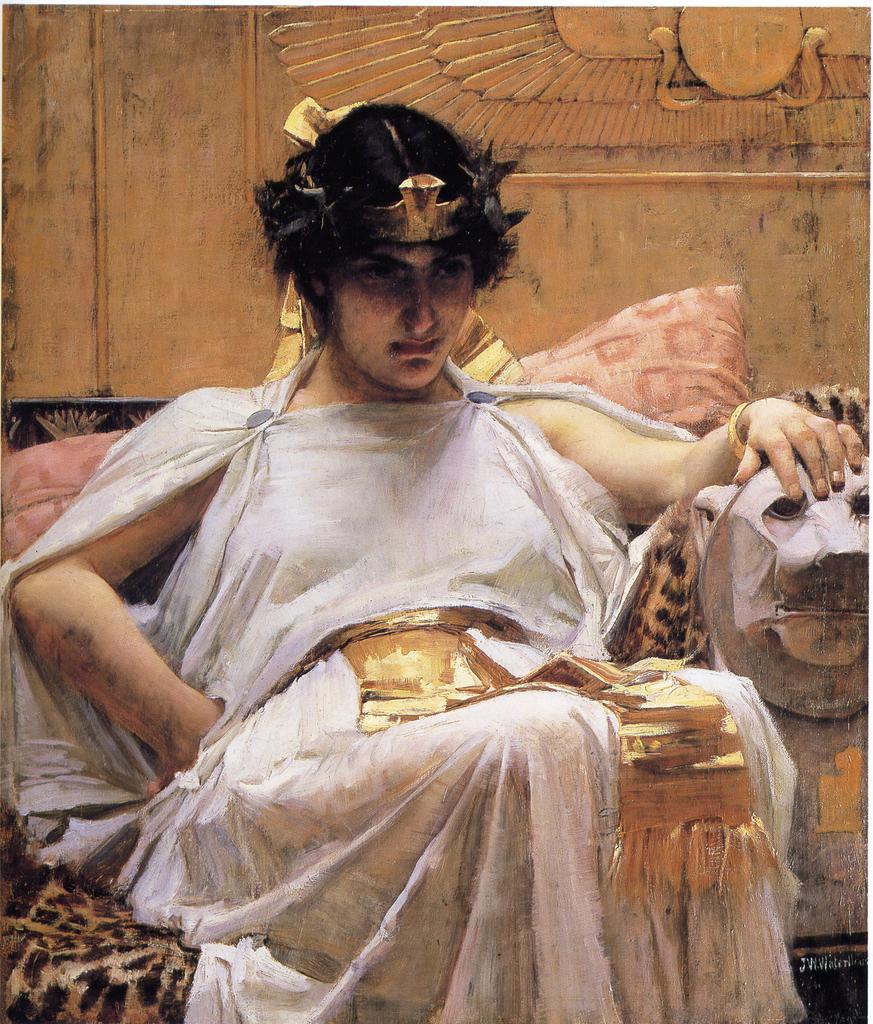Describe this image in one or two sentences. In this picture we can observe a woman sitting in the sofa wearing white color dress. On the right side we can observe status of an animal. In the background there is a wall which is in yellow color. We can observe carving on the wall. 